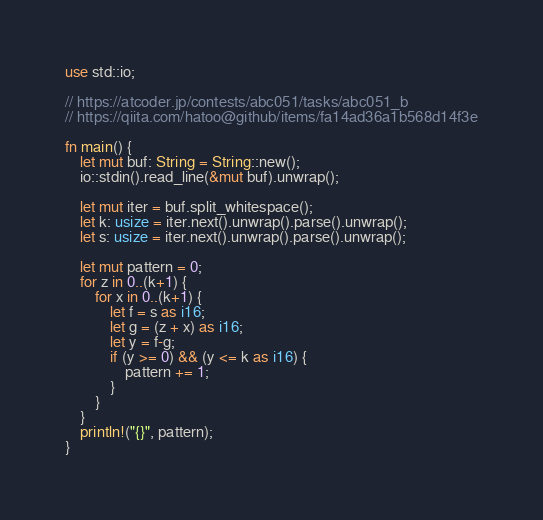<code> <loc_0><loc_0><loc_500><loc_500><_Rust_>use std::io;

// https://atcoder.jp/contests/abc051/tasks/abc051_b
// https://qiita.com/hatoo@github/items/fa14ad36a1b568d14f3e

fn main() {
    let mut buf: String = String::new();
    io::stdin().read_line(&mut buf).unwrap();

    let mut iter = buf.split_whitespace();
    let k: usize = iter.next().unwrap().parse().unwrap();
    let s: usize = iter.next().unwrap().parse().unwrap();

    let mut pattern = 0;
    for z in 0..(k+1) {
        for x in 0..(k+1) {
            let f = s as i16;
            let g = (z + x) as i16;
            let y = f-g;
            if (y >= 0) && (y <= k as i16) {
                pattern += 1;
            }
        }
    }
    println!("{}", pattern);
}</code> 